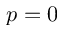Convert formula to latex. <formula><loc_0><loc_0><loc_500><loc_500>p = 0</formula> 